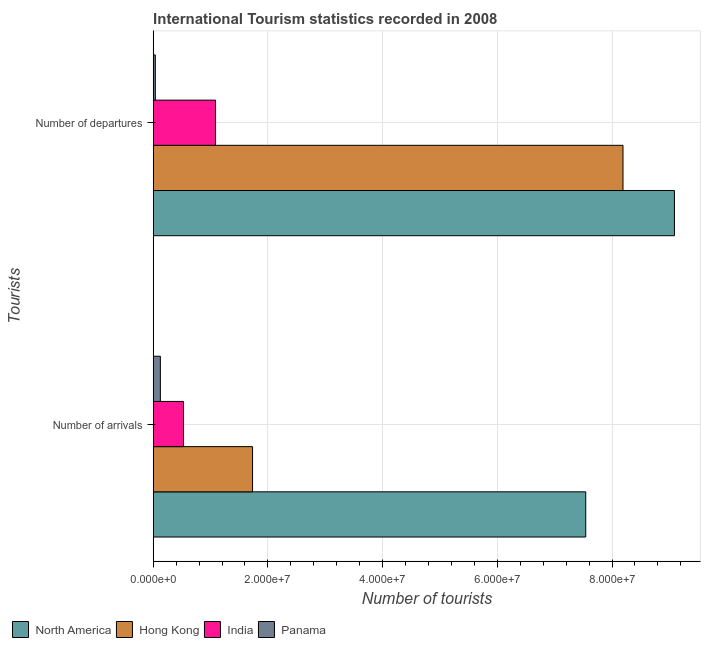Are the number of bars per tick equal to the number of legend labels?
Give a very brief answer. Yes. How many bars are there on the 2nd tick from the bottom?
Offer a terse response. 4. What is the label of the 1st group of bars from the top?
Ensure brevity in your answer.  Number of departures. What is the number of tourist arrivals in Hong Kong?
Offer a very short reply. 1.73e+07. Across all countries, what is the maximum number of tourist arrivals?
Offer a terse response. 7.54e+07. Across all countries, what is the minimum number of tourist arrivals?
Make the answer very short. 1.25e+06. In which country was the number of tourist departures maximum?
Give a very brief answer. North America. In which country was the number of tourist arrivals minimum?
Your answer should be compact. Panama. What is the total number of tourist arrivals in the graph?
Your response must be concise. 9.93e+07. What is the difference between the number of tourist arrivals in Panama and that in Hong Kong?
Ensure brevity in your answer.  -1.61e+07. What is the difference between the number of tourist arrivals in Panama and the number of tourist departures in North America?
Make the answer very short. -8.96e+07. What is the average number of tourist departures per country?
Make the answer very short. 4.60e+07. What is the difference between the number of tourist departures and number of tourist arrivals in Hong Kong?
Make the answer very short. 6.46e+07. What is the ratio of the number of tourist arrivals in North America to that in India?
Give a very brief answer. 14.27. Is the number of tourist arrivals in North America less than that in India?
Provide a short and direct response. No. In how many countries, is the number of tourist departures greater than the average number of tourist departures taken over all countries?
Provide a succinct answer. 2. What does the 2nd bar from the top in Number of arrivals represents?
Provide a succinct answer. India. What does the 1st bar from the bottom in Number of arrivals represents?
Your response must be concise. North America. How many countries are there in the graph?
Give a very brief answer. 4. Are the values on the major ticks of X-axis written in scientific E-notation?
Make the answer very short. Yes. How many legend labels are there?
Your answer should be very brief. 4. What is the title of the graph?
Your response must be concise. International Tourism statistics recorded in 2008. What is the label or title of the X-axis?
Make the answer very short. Number of tourists. What is the label or title of the Y-axis?
Make the answer very short. Tourists. What is the Number of tourists in North America in Number of arrivals?
Your answer should be compact. 7.54e+07. What is the Number of tourists in Hong Kong in Number of arrivals?
Your answer should be compact. 1.73e+07. What is the Number of tourists in India in Number of arrivals?
Keep it short and to the point. 5.28e+06. What is the Number of tourists in Panama in Number of arrivals?
Your response must be concise. 1.25e+06. What is the Number of tourists of North America in Number of departures?
Provide a short and direct response. 9.09e+07. What is the Number of tourists of Hong Kong in Number of departures?
Offer a terse response. 8.19e+07. What is the Number of tourists of India in Number of departures?
Ensure brevity in your answer.  1.09e+07. What is the Number of tourists in Panama in Number of departures?
Offer a terse response. 3.69e+05. Across all Tourists, what is the maximum Number of tourists in North America?
Ensure brevity in your answer.  9.09e+07. Across all Tourists, what is the maximum Number of tourists in Hong Kong?
Make the answer very short. 8.19e+07. Across all Tourists, what is the maximum Number of tourists in India?
Provide a short and direct response. 1.09e+07. Across all Tourists, what is the maximum Number of tourists in Panama?
Offer a terse response. 1.25e+06. Across all Tourists, what is the minimum Number of tourists in North America?
Your answer should be compact. 7.54e+07. Across all Tourists, what is the minimum Number of tourists of Hong Kong?
Your answer should be compact. 1.73e+07. Across all Tourists, what is the minimum Number of tourists of India?
Make the answer very short. 5.28e+06. Across all Tourists, what is the minimum Number of tourists in Panama?
Your answer should be compact. 3.69e+05. What is the total Number of tourists of North America in the graph?
Keep it short and to the point. 1.66e+08. What is the total Number of tourists of Hong Kong in the graph?
Offer a terse response. 9.92e+07. What is the total Number of tourists of India in the graph?
Your response must be concise. 1.62e+07. What is the total Number of tourists of Panama in the graph?
Offer a terse response. 1.62e+06. What is the difference between the Number of tourists of North America in Number of arrivals and that in Number of departures?
Your response must be concise. -1.55e+07. What is the difference between the Number of tourists of Hong Kong in Number of arrivals and that in Number of departures?
Offer a terse response. -6.46e+07. What is the difference between the Number of tourists of India in Number of arrivals and that in Number of departures?
Make the answer very short. -5.58e+06. What is the difference between the Number of tourists of Panama in Number of arrivals and that in Number of departures?
Keep it short and to the point. 8.78e+05. What is the difference between the Number of tourists in North America in Number of arrivals and the Number of tourists in Hong Kong in Number of departures?
Keep it short and to the point. -6.50e+06. What is the difference between the Number of tourists in North America in Number of arrivals and the Number of tourists in India in Number of departures?
Make the answer very short. 6.45e+07. What is the difference between the Number of tourists of North America in Number of arrivals and the Number of tourists of Panama in Number of departures?
Give a very brief answer. 7.50e+07. What is the difference between the Number of tourists of Hong Kong in Number of arrivals and the Number of tourists of India in Number of departures?
Make the answer very short. 6.45e+06. What is the difference between the Number of tourists of Hong Kong in Number of arrivals and the Number of tourists of Panama in Number of departures?
Offer a terse response. 1.70e+07. What is the difference between the Number of tourists in India in Number of arrivals and the Number of tourists in Panama in Number of departures?
Your answer should be very brief. 4.91e+06. What is the average Number of tourists of North America per Tourists?
Ensure brevity in your answer.  8.31e+07. What is the average Number of tourists in Hong Kong per Tourists?
Make the answer very short. 4.96e+07. What is the average Number of tourists in India per Tourists?
Ensure brevity in your answer.  8.08e+06. What is the average Number of tourists of Panama per Tourists?
Offer a terse response. 8.08e+05. What is the difference between the Number of tourists of North America and Number of tourists of Hong Kong in Number of arrivals?
Offer a terse response. 5.81e+07. What is the difference between the Number of tourists in North America and Number of tourists in India in Number of arrivals?
Offer a terse response. 7.01e+07. What is the difference between the Number of tourists of North America and Number of tourists of Panama in Number of arrivals?
Provide a short and direct response. 7.42e+07. What is the difference between the Number of tourists in Hong Kong and Number of tourists in India in Number of arrivals?
Offer a terse response. 1.20e+07. What is the difference between the Number of tourists of Hong Kong and Number of tourists of Panama in Number of arrivals?
Your response must be concise. 1.61e+07. What is the difference between the Number of tourists of India and Number of tourists of Panama in Number of arrivals?
Make the answer very short. 4.04e+06. What is the difference between the Number of tourists in North America and Number of tourists in Hong Kong in Number of departures?
Provide a short and direct response. 8.97e+06. What is the difference between the Number of tourists in North America and Number of tourists in India in Number of departures?
Keep it short and to the point. 8.00e+07. What is the difference between the Number of tourists in North America and Number of tourists in Panama in Number of departures?
Keep it short and to the point. 9.05e+07. What is the difference between the Number of tourists of Hong Kong and Number of tourists of India in Number of departures?
Keep it short and to the point. 7.10e+07. What is the difference between the Number of tourists in Hong Kong and Number of tourists in Panama in Number of departures?
Ensure brevity in your answer.  8.15e+07. What is the difference between the Number of tourists of India and Number of tourists of Panama in Number of departures?
Provide a succinct answer. 1.05e+07. What is the ratio of the Number of tourists in North America in Number of arrivals to that in Number of departures?
Offer a very short reply. 0.83. What is the ratio of the Number of tourists in Hong Kong in Number of arrivals to that in Number of departures?
Provide a succinct answer. 0.21. What is the ratio of the Number of tourists of India in Number of arrivals to that in Number of departures?
Your response must be concise. 0.49. What is the ratio of the Number of tourists of Panama in Number of arrivals to that in Number of departures?
Offer a very short reply. 3.38. What is the difference between the highest and the second highest Number of tourists of North America?
Ensure brevity in your answer.  1.55e+07. What is the difference between the highest and the second highest Number of tourists of Hong Kong?
Your answer should be compact. 6.46e+07. What is the difference between the highest and the second highest Number of tourists in India?
Your answer should be very brief. 5.58e+06. What is the difference between the highest and the second highest Number of tourists of Panama?
Offer a terse response. 8.78e+05. What is the difference between the highest and the lowest Number of tourists in North America?
Keep it short and to the point. 1.55e+07. What is the difference between the highest and the lowest Number of tourists in Hong Kong?
Your answer should be compact. 6.46e+07. What is the difference between the highest and the lowest Number of tourists of India?
Your answer should be compact. 5.58e+06. What is the difference between the highest and the lowest Number of tourists of Panama?
Your response must be concise. 8.78e+05. 